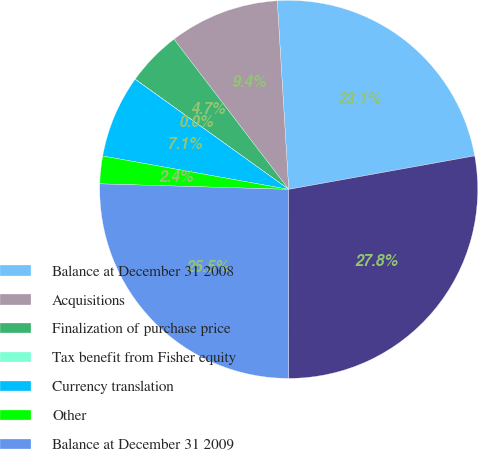Convert chart. <chart><loc_0><loc_0><loc_500><loc_500><pie_chart><fcel>Balance at December 31 2008<fcel>Acquisitions<fcel>Finalization of purchase price<fcel>Tax benefit from Fisher equity<fcel>Currency translation<fcel>Other<fcel>Balance at December 31 2009<fcel>Balance at December 31 2010<nl><fcel>23.13%<fcel>9.42%<fcel>4.71%<fcel>0.01%<fcel>7.07%<fcel>2.36%<fcel>25.48%<fcel>27.83%<nl></chart> 